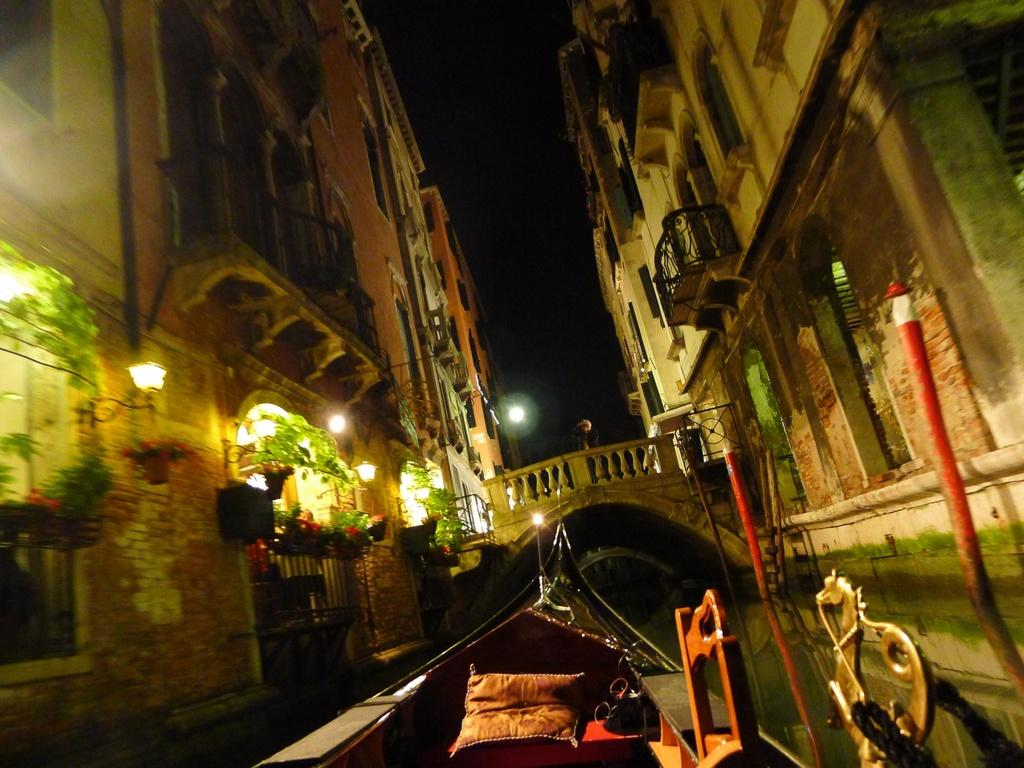What type of structures can be seen in the image? There are buildings in the image. What other elements are present in the image besides buildings? There are plants, lights, flowers, a bridge, poles, water, a boat, and the sky visible in the image. Can you describe the natural elements in the image? There are plants and flowers, as well as water visible in the image. What type of transportation is present in the image? There is a boat in the image. What is the condition of the sky in the image? The sky is visible in the image. How many cakes are being served on the boat in the image? There are no cakes present in the image; it features a boat in the water. What type of achievement is the boat celebrating in the image? There is no indication in the image that the boat is celebrating any achievement. 